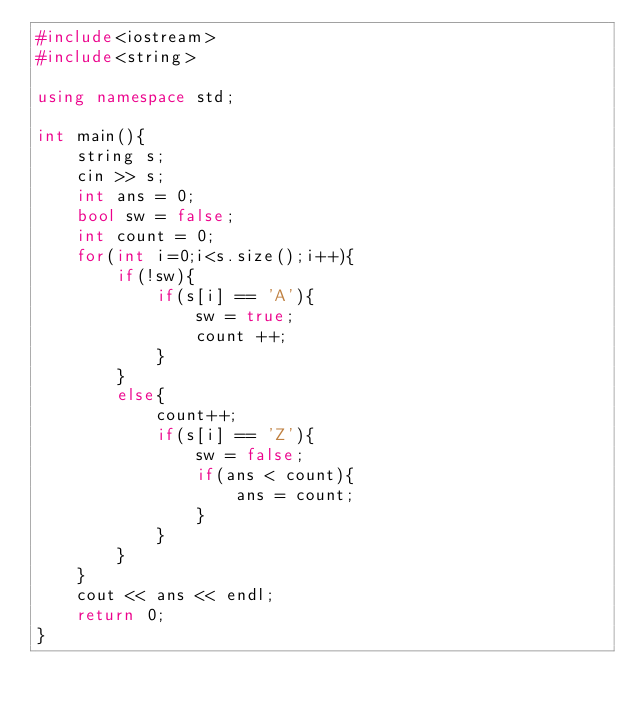Convert code to text. <code><loc_0><loc_0><loc_500><loc_500><_C++_>#include<iostream>
#include<string>

using namespace std;

int main(){
    string s;
    cin >> s;
    int ans = 0;
    bool sw = false;
    int count = 0;
    for(int i=0;i<s.size();i++){
        if(!sw){
            if(s[i] == 'A'){
                sw = true;
                count ++;
            }
        }
        else{
            count++;
            if(s[i] == 'Z'){
                sw = false;
                if(ans < count){
                    ans = count;
                }
            }
        }
    }
    cout << ans << endl;
    return 0;
}</code> 